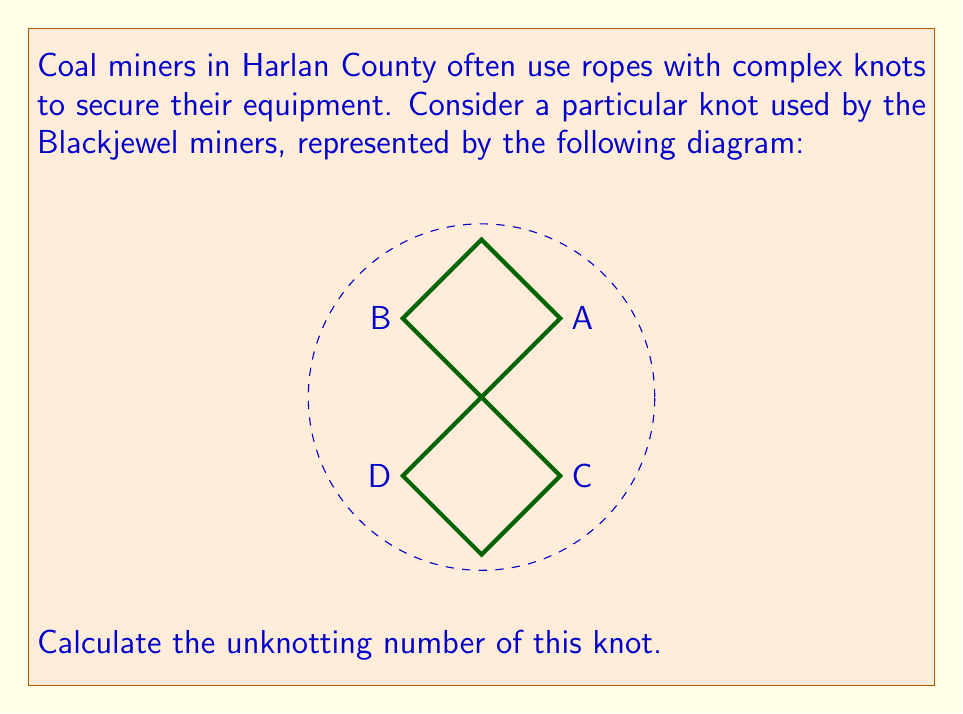Show me your answer to this math problem. To determine the unknotting number of this knot, we need to follow these steps:

1) First, let's identify the knot. The diagram shows a figure-eight knot, which is one of the simplest non-trivial knots.

2) The unknotting number of a knot is the minimum number of crossing changes required to transform the knot into the unknot (trivial knot).

3) For the figure-eight knot:
   - It has 4 crossings (labeled A, B, C, and D in the diagram).
   - It is known to be an alternating knot (over-under-over-under pattern).
   - It is also known to be a prime knot (cannot be decomposed into simpler knots).

4) A key theorem in knot theory states that for any non-trivial alternating knot, its unknotting number is always less than or equal to half the number of its crossings. In mathematical notation:

   $$ u(K) \leq \frac{1}{2}c(K) $$

   where $u(K)$ is the unknotting number and $c(K)$ is the crossing number.

5) For our figure-eight knot:
   $$ u(K) \leq \frac{1}{2} \cdot 4 = 2 $$

6) However, it's known that changing any single crossing of the figure-eight knot results in the trivial knot.

Therefore, the unknotting number of the figure-eight knot is 1.
Answer: 1 